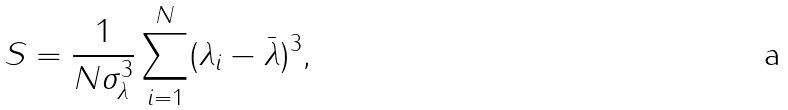<formula> <loc_0><loc_0><loc_500><loc_500>S = \frac { 1 } { N \sigma _ { \lambda } ^ { 3 } } \sum _ { i = 1 } ^ { N } ( \lambda _ { i } - \bar { \lambda } ) ^ { 3 } ,</formula> 